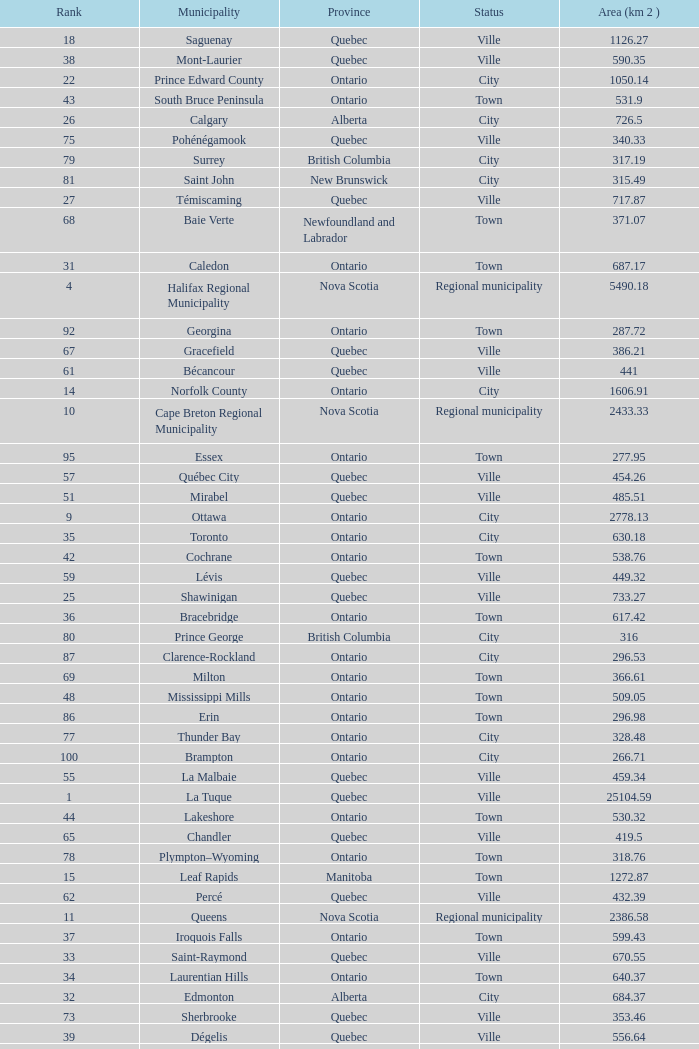What is the highest Area (KM 2) for the Province of Ontario, that has the Status of Town, a Municipality of Minto, and a Rank that's smaller than 84? None. 